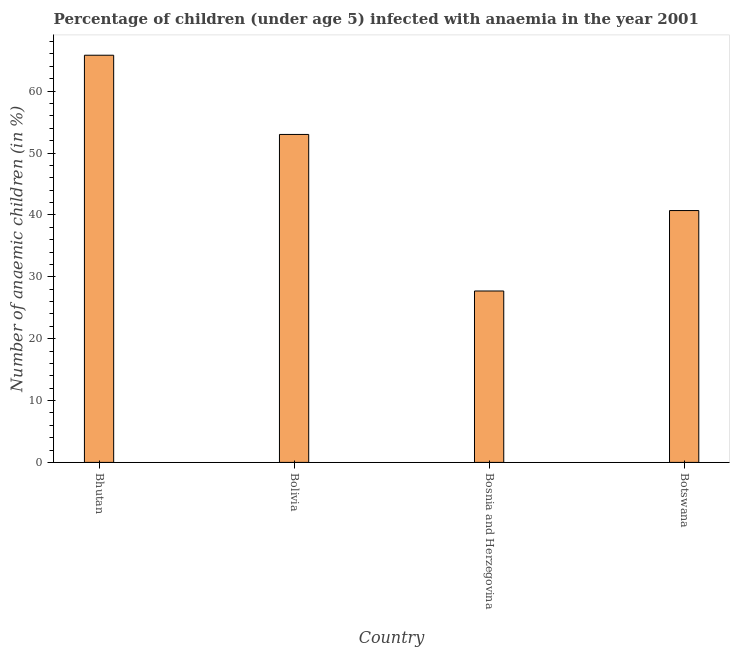Does the graph contain any zero values?
Keep it short and to the point. No. What is the title of the graph?
Give a very brief answer. Percentage of children (under age 5) infected with anaemia in the year 2001. What is the label or title of the X-axis?
Your answer should be compact. Country. What is the label or title of the Y-axis?
Provide a short and direct response. Number of anaemic children (in %). What is the number of anaemic children in Bolivia?
Your response must be concise. 53. Across all countries, what is the maximum number of anaemic children?
Provide a short and direct response. 65.8. Across all countries, what is the minimum number of anaemic children?
Your answer should be very brief. 27.7. In which country was the number of anaemic children maximum?
Your answer should be very brief. Bhutan. In which country was the number of anaemic children minimum?
Your response must be concise. Bosnia and Herzegovina. What is the sum of the number of anaemic children?
Keep it short and to the point. 187.2. What is the difference between the number of anaemic children in Bolivia and Bosnia and Herzegovina?
Provide a succinct answer. 25.3. What is the average number of anaemic children per country?
Offer a terse response. 46.8. What is the median number of anaemic children?
Ensure brevity in your answer.  46.85. What is the ratio of the number of anaemic children in Bolivia to that in Bosnia and Herzegovina?
Provide a short and direct response. 1.91. Is the number of anaemic children in Bhutan less than that in Botswana?
Provide a short and direct response. No. Is the difference between the number of anaemic children in Bolivia and Botswana greater than the difference between any two countries?
Make the answer very short. No. What is the difference between the highest and the second highest number of anaemic children?
Your answer should be compact. 12.8. What is the difference between the highest and the lowest number of anaemic children?
Provide a short and direct response. 38.1. In how many countries, is the number of anaemic children greater than the average number of anaemic children taken over all countries?
Provide a succinct answer. 2. How many bars are there?
Offer a terse response. 4. Are all the bars in the graph horizontal?
Offer a very short reply. No. How many countries are there in the graph?
Provide a short and direct response. 4. Are the values on the major ticks of Y-axis written in scientific E-notation?
Make the answer very short. No. What is the Number of anaemic children (in %) in Bhutan?
Your response must be concise. 65.8. What is the Number of anaemic children (in %) of Bolivia?
Offer a very short reply. 53. What is the Number of anaemic children (in %) in Bosnia and Herzegovina?
Offer a terse response. 27.7. What is the Number of anaemic children (in %) of Botswana?
Offer a very short reply. 40.7. What is the difference between the Number of anaemic children (in %) in Bhutan and Bolivia?
Make the answer very short. 12.8. What is the difference between the Number of anaemic children (in %) in Bhutan and Bosnia and Herzegovina?
Offer a very short reply. 38.1. What is the difference between the Number of anaemic children (in %) in Bhutan and Botswana?
Your answer should be very brief. 25.1. What is the difference between the Number of anaemic children (in %) in Bolivia and Bosnia and Herzegovina?
Keep it short and to the point. 25.3. What is the difference between the Number of anaemic children (in %) in Bolivia and Botswana?
Make the answer very short. 12.3. What is the difference between the Number of anaemic children (in %) in Bosnia and Herzegovina and Botswana?
Provide a succinct answer. -13. What is the ratio of the Number of anaemic children (in %) in Bhutan to that in Bolivia?
Offer a terse response. 1.24. What is the ratio of the Number of anaemic children (in %) in Bhutan to that in Bosnia and Herzegovina?
Your response must be concise. 2.38. What is the ratio of the Number of anaemic children (in %) in Bhutan to that in Botswana?
Offer a terse response. 1.62. What is the ratio of the Number of anaemic children (in %) in Bolivia to that in Bosnia and Herzegovina?
Give a very brief answer. 1.91. What is the ratio of the Number of anaemic children (in %) in Bolivia to that in Botswana?
Provide a succinct answer. 1.3. What is the ratio of the Number of anaemic children (in %) in Bosnia and Herzegovina to that in Botswana?
Your answer should be compact. 0.68. 